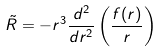Convert formula to latex. <formula><loc_0><loc_0><loc_500><loc_500>\tilde { R } = - r ^ { 3 } \frac { d ^ { 2 } } { d r ^ { 2 } } \left ( \frac { f ( r ) } { r } \right )</formula> 